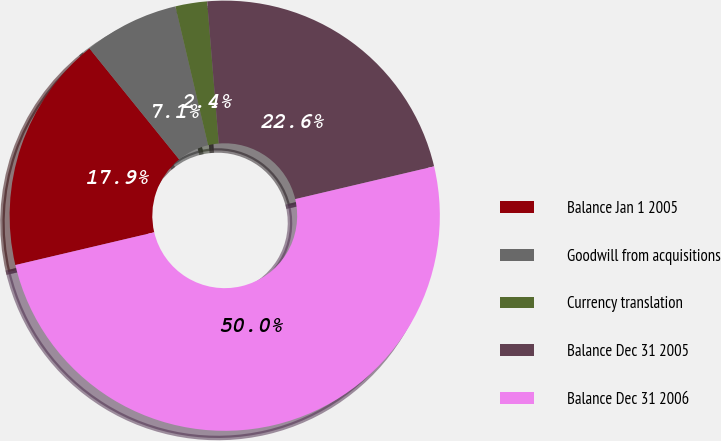Convert chart. <chart><loc_0><loc_0><loc_500><loc_500><pie_chart><fcel>Balance Jan 1 2005<fcel>Goodwill from acquisitions<fcel>Currency translation<fcel>Balance Dec 31 2005<fcel>Balance Dec 31 2006<nl><fcel>17.86%<fcel>7.14%<fcel>2.38%<fcel>22.62%<fcel>50.0%<nl></chart> 